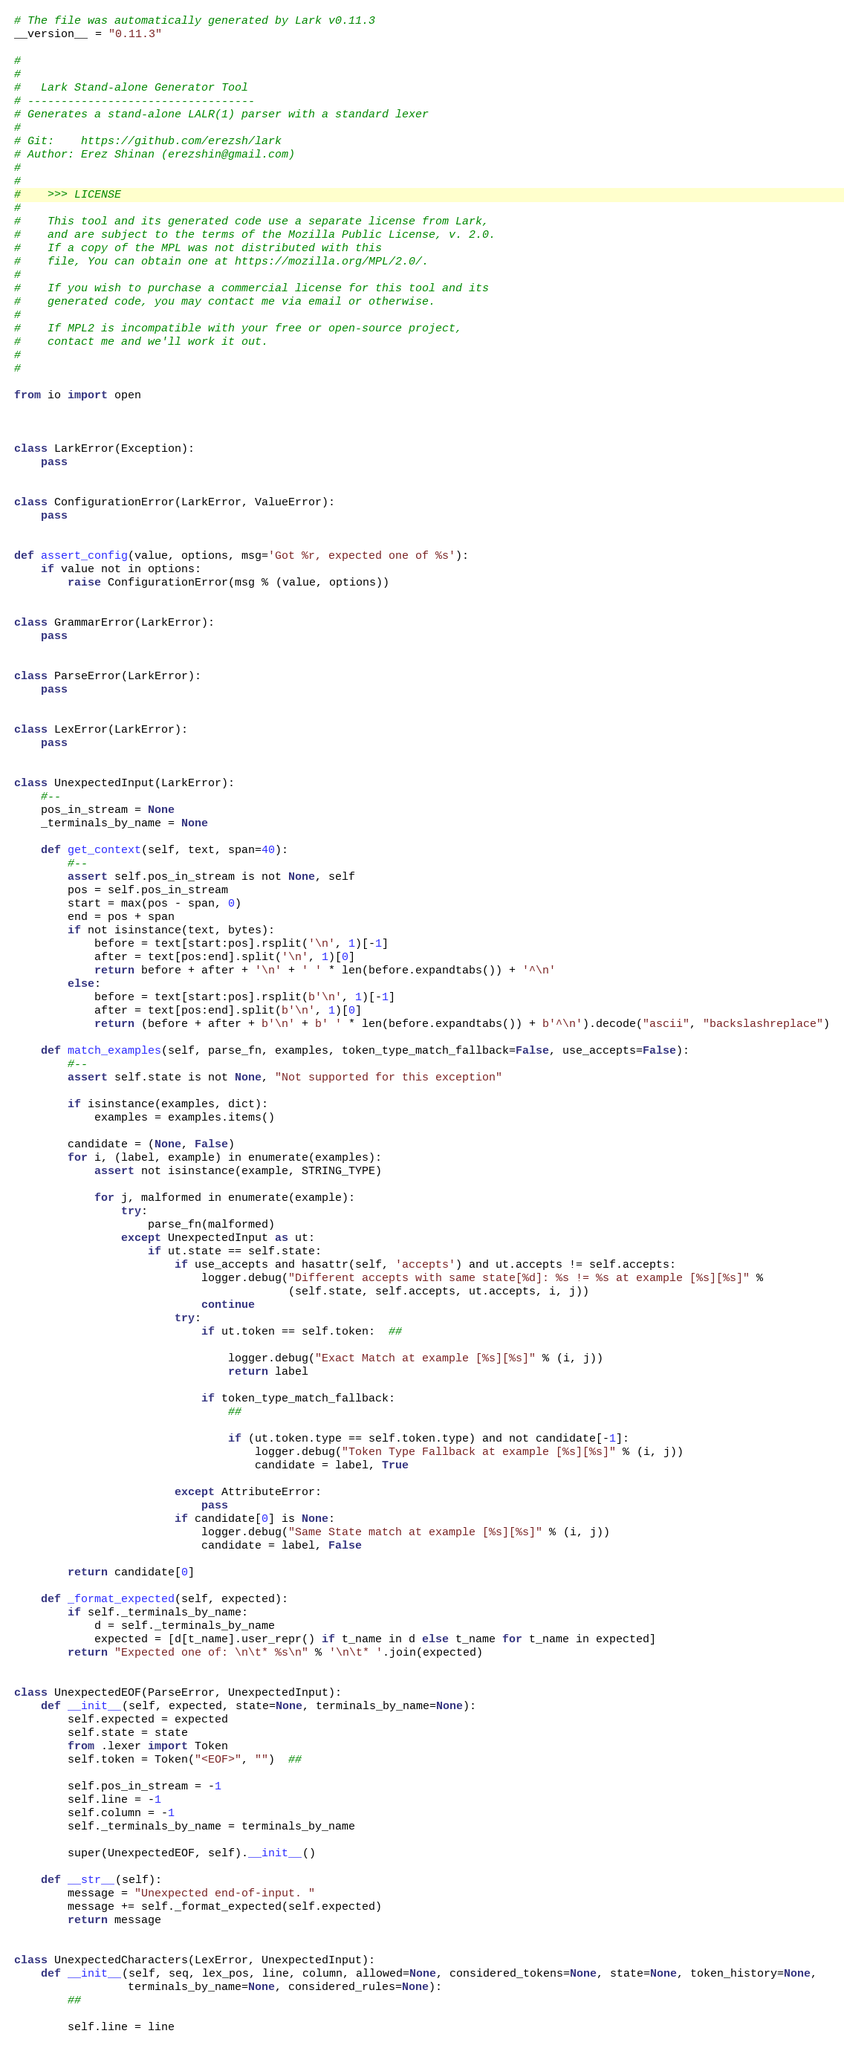Convert code to text. <code><loc_0><loc_0><loc_500><loc_500><_Python_># The file was automatically generated by Lark v0.11.3
__version__ = "0.11.3"

#
#
#   Lark Stand-alone Generator Tool
# ----------------------------------
# Generates a stand-alone LALR(1) parser with a standard lexer
#
# Git:    https://github.com/erezsh/lark
# Author: Erez Shinan (erezshin@gmail.com)
#
#
#    >>> LICENSE
#
#    This tool and its generated code use a separate license from Lark,
#    and are subject to the terms of the Mozilla Public License, v. 2.0.
#    If a copy of the MPL was not distributed with this
#    file, You can obtain one at https://mozilla.org/MPL/2.0/.
#
#    If you wish to purchase a commercial license for this tool and its
#    generated code, you may contact me via email or otherwise.
#
#    If MPL2 is incompatible with your free or open-source project,
#    contact me and we'll work it out.
#
#

from io import open



class LarkError(Exception):
    pass


class ConfigurationError(LarkError, ValueError):
    pass


def assert_config(value, options, msg='Got %r, expected one of %s'):
    if value not in options:
        raise ConfigurationError(msg % (value, options))


class GrammarError(LarkError):
    pass


class ParseError(LarkError):
    pass


class LexError(LarkError):
    pass


class UnexpectedInput(LarkError):
    #--
    pos_in_stream = None
    _terminals_by_name = None

    def get_context(self, text, span=40):
        #--
        assert self.pos_in_stream is not None, self
        pos = self.pos_in_stream
        start = max(pos - span, 0)
        end = pos + span
        if not isinstance(text, bytes):
            before = text[start:pos].rsplit('\n', 1)[-1]
            after = text[pos:end].split('\n', 1)[0]
            return before + after + '\n' + ' ' * len(before.expandtabs()) + '^\n'
        else:
            before = text[start:pos].rsplit(b'\n', 1)[-1]
            after = text[pos:end].split(b'\n', 1)[0]
            return (before + after + b'\n' + b' ' * len(before.expandtabs()) + b'^\n').decode("ascii", "backslashreplace")

    def match_examples(self, parse_fn, examples, token_type_match_fallback=False, use_accepts=False):
        #--
        assert self.state is not None, "Not supported for this exception"

        if isinstance(examples, dict):
            examples = examples.items()

        candidate = (None, False)
        for i, (label, example) in enumerate(examples):
            assert not isinstance(example, STRING_TYPE)

            for j, malformed in enumerate(example):
                try:
                    parse_fn(malformed)
                except UnexpectedInput as ut:
                    if ut.state == self.state:
                        if use_accepts and hasattr(self, 'accepts') and ut.accepts != self.accepts:
                            logger.debug("Different accepts with same state[%d]: %s != %s at example [%s][%s]" %
                                         (self.state, self.accepts, ut.accepts, i, j))
                            continue
                        try:
                            if ut.token == self.token:  ##

                                logger.debug("Exact Match at example [%s][%s]" % (i, j))
                                return label

                            if token_type_match_fallback:
                                ##

                                if (ut.token.type == self.token.type) and not candidate[-1]:
                                    logger.debug("Token Type Fallback at example [%s][%s]" % (i, j))
                                    candidate = label, True

                        except AttributeError:
                            pass
                        if candidate[0] is None:
                            logger.debug("Same State match at example [%s][%s]" % (i, j))
                            candidate = label, False

        return candidate[0]

    def _format_expected(self, expected):
        if self._terminals_by_name:
            d = self._terminals_by_name
            expected = [d[t_name].user_repr() if t_name in d else t_name for t_name in expected]
        return "Expected one of: \n\t* %s\n" % '\n\t* '.join(expected)


class UnexpectedEOF(ParseError, UnexpectedInput):
    def __init__(self, expected, state=None, terminals_by_name=None):
        self.expected = expected
        self.state = state
        from .lexer import Token
        self.token = Token("<EOF>", "")  ##

        self.pos_in_stream = -1
        self.line = -1
        self.column = -1
        self._terminals_by_name = terminals_by_name

        super(UnexpectedEOF, self).__init__()

    def __str__(self):
        message = "Unexpected end-of-input. "
        message += self._format_expected(self.expected)
        return message


class UnexpectedCharacters(LexError, UnexpectedInput):
    def __init__(self, seq, lex_pos, line, column, allowed=None, considered_tokens=None, state=None, token_history=None,
                 terminals_by_name=None, considered_rules=None):
        ##

        self.line = line</code> 